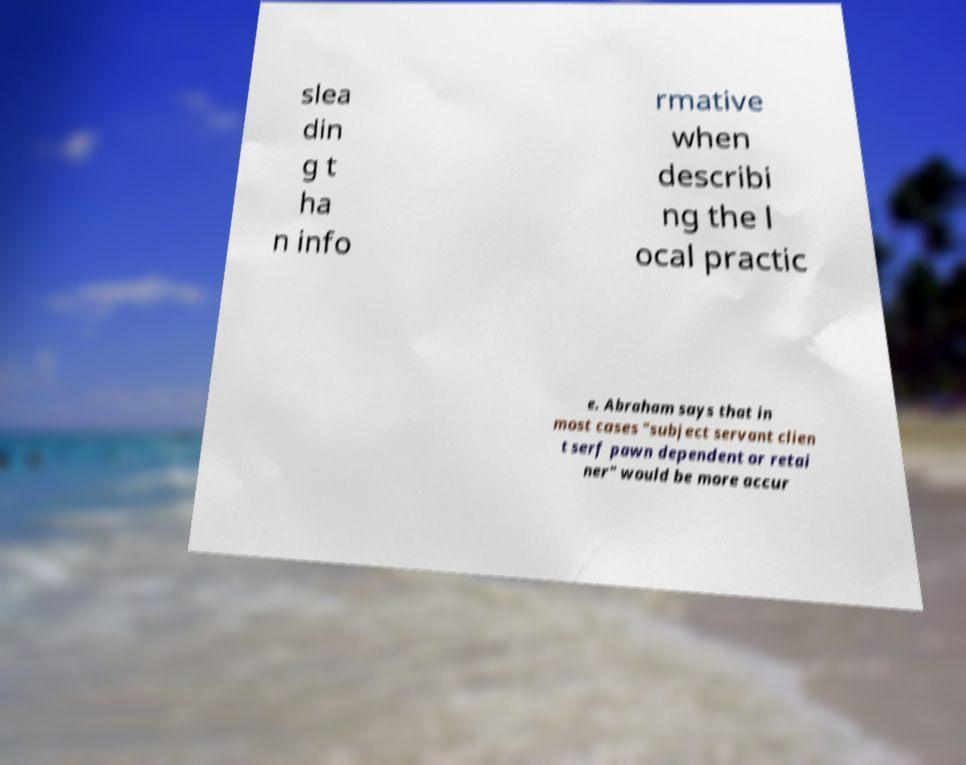I need the written content from this picture converted into text. Can you do that? slea din g t ha n info rmative when describi ng the l ocal practic e. Abraham says that in most cases "subject servant clien t serf pawn dependent or retai ner" would be more accur 